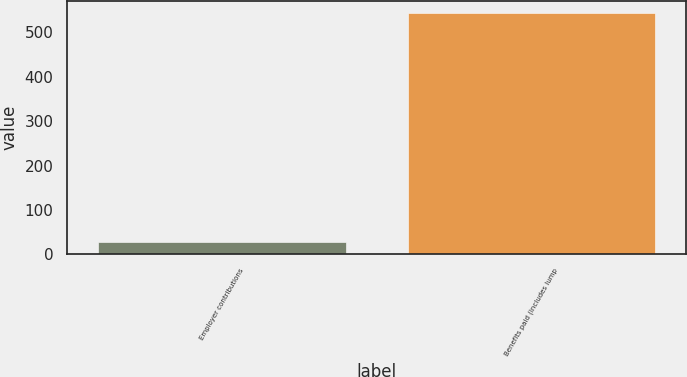Convert chart. <chart><loc_0><loc_0><loc_500><loc_500><bar_chart><fcel>Employer contributions<fcel>Benefits paid (includes lump<nl><fcel>28<fcel>544<nl></chart> 